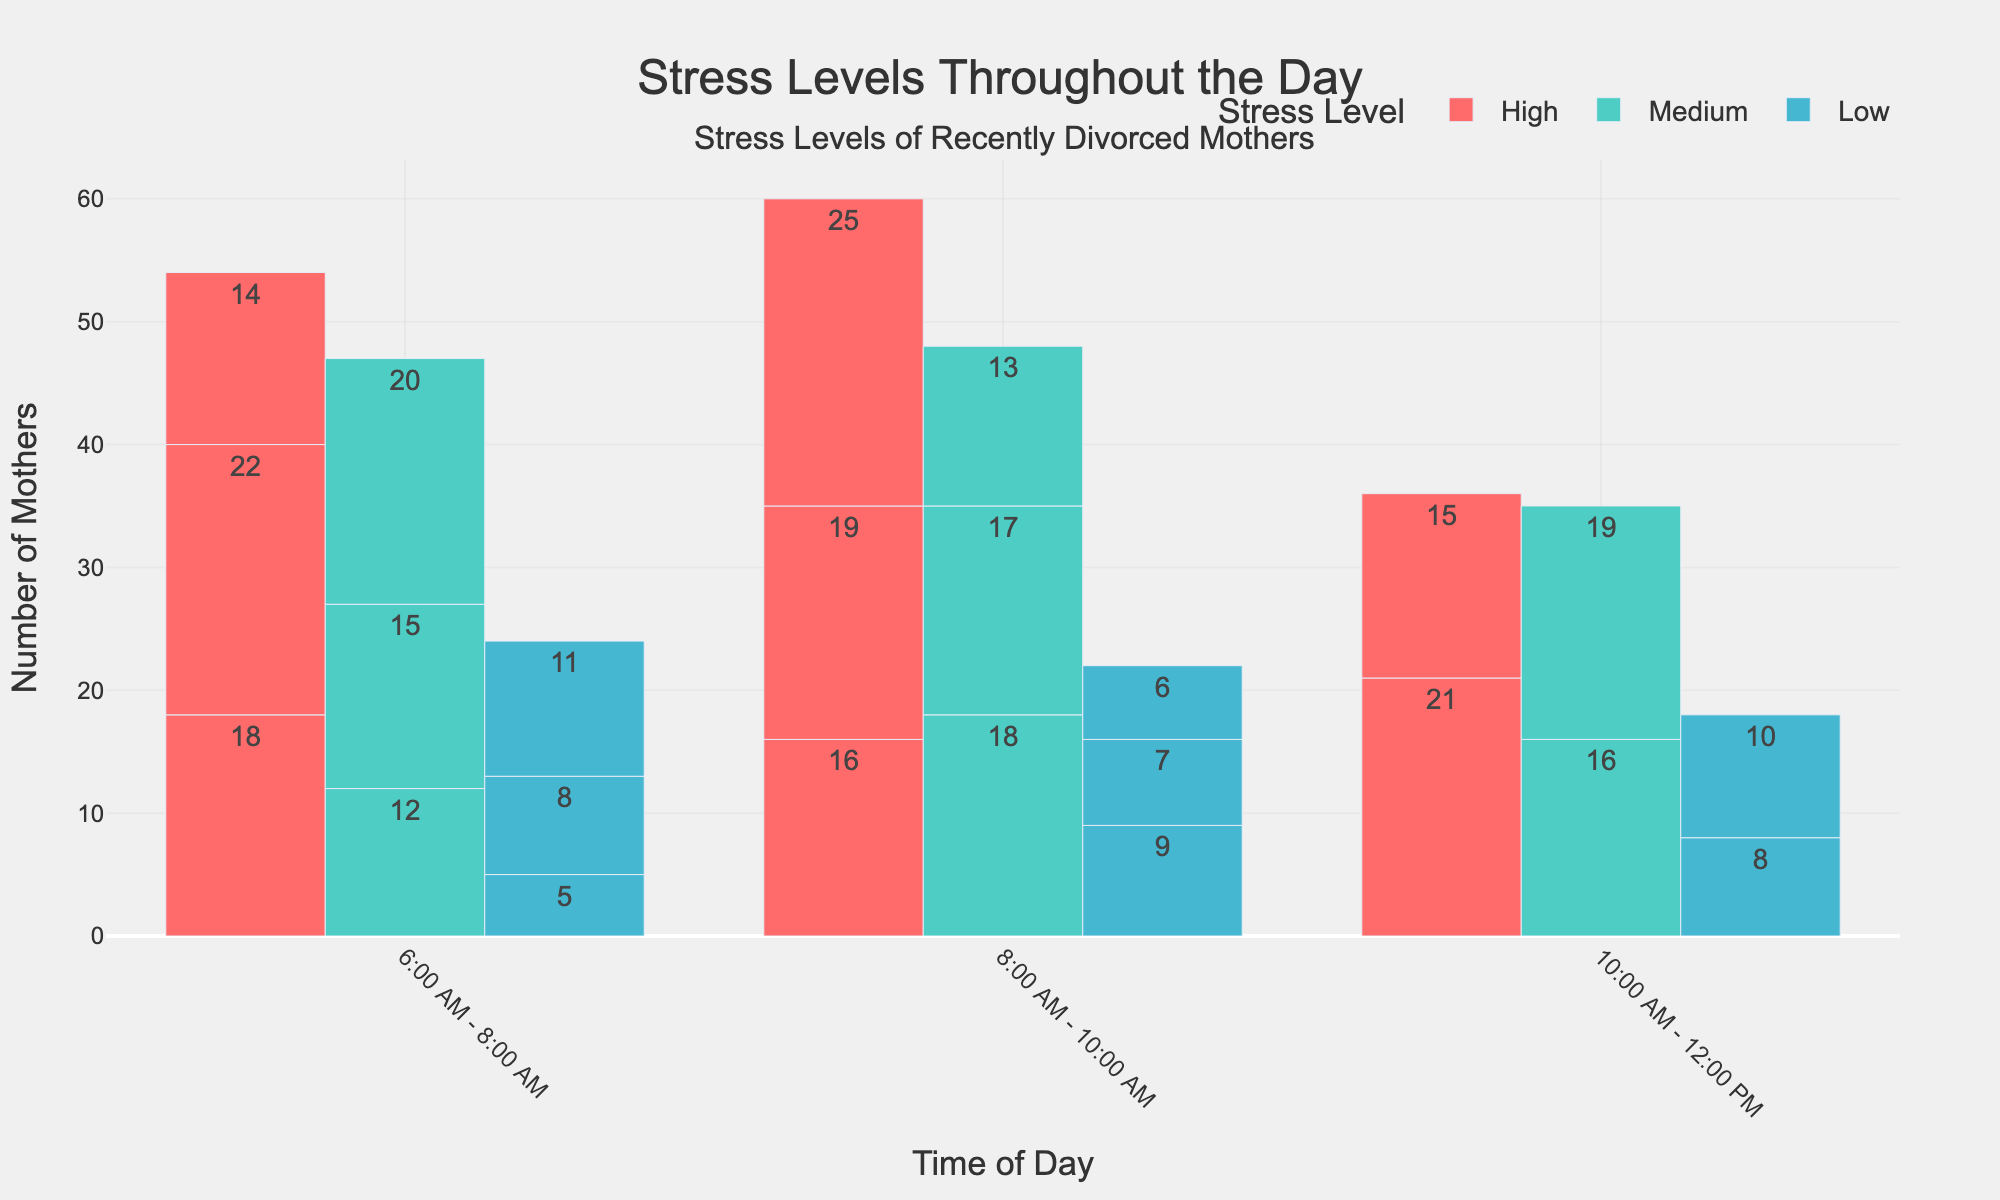What's the time period with the highest number of mothers reporting high stress levels? To find the time period with the highest number of mothers reporting high stress levels, look at the bar chart and identify the tallest bar for the 'High' category.
Answer: 4:00 PM - 6:00 PM What's the total number of mothers reporting medium stress levels between 10:00 AM - 2:00 PM? Add the counts for the 'Medium' stress level from 10:00 AM - 12:00 PM and 12:00 PM - 2:00 PM. 20 + 18 = 38
Answer: 38 What is the difference in the count of high stress levels reported between 6:00 AM - 8:00 AM and 6:00 PM - 8:00 PM? Subtract the count of high stress levels at 6:00 AM - 8:00 AM from the count at 6:00 PM - 8:00 PM. 21 - 18 = 3
Answer: 3 How many mothers reported low stress levels in the time period when the highest medium stress level was reported? Identify the period with the highest medium stress level (8:00 PM - 10:00 PM) and then find the count for low stress levels in the same time period.
Answer: 10 Which time period has the same number of mothers reporting low stress levels as the count of high stress levels reported at 10:00 AM - 12:00 PM? Look at the count for high stress level at 10:00 AM - 12:00 PM (14) and find a time period with the same count for low stress levels (8:00 PM - 10:00 PM).
Answer: 8:00 PM - 10:00 PM Are there more mothers reporting high stress in the morning (6:00 AM - 12:00 PM) compared to the afternoon (12:00 PM - 6:00 PM)? Sum the counts of high stress levels for morning (18 + 22 + 14) and afternoon (16 + 19). Morning: 18 + 22 + 14 = 54, Afternoon: 16 + 19 + 25 = 60. No, there are more in the afternoon.
Answer: No Which period had the lowest number of mothers reporting medium stress levels? Compare the medium stress levels for each period to find the lowest count (6:00 AM - 8:00 AM).
Answer: 6:00 AM - 8:00 AM What is the average number of mothers reporting low stress levels throughout the day? Sum the counts of low stress levels for all periods and divide by the number of periods. (5 + 8 + 11 + 9 + 7 + 6 + 8 + 10)/8 = 64/8 = 8
Answer: 8 